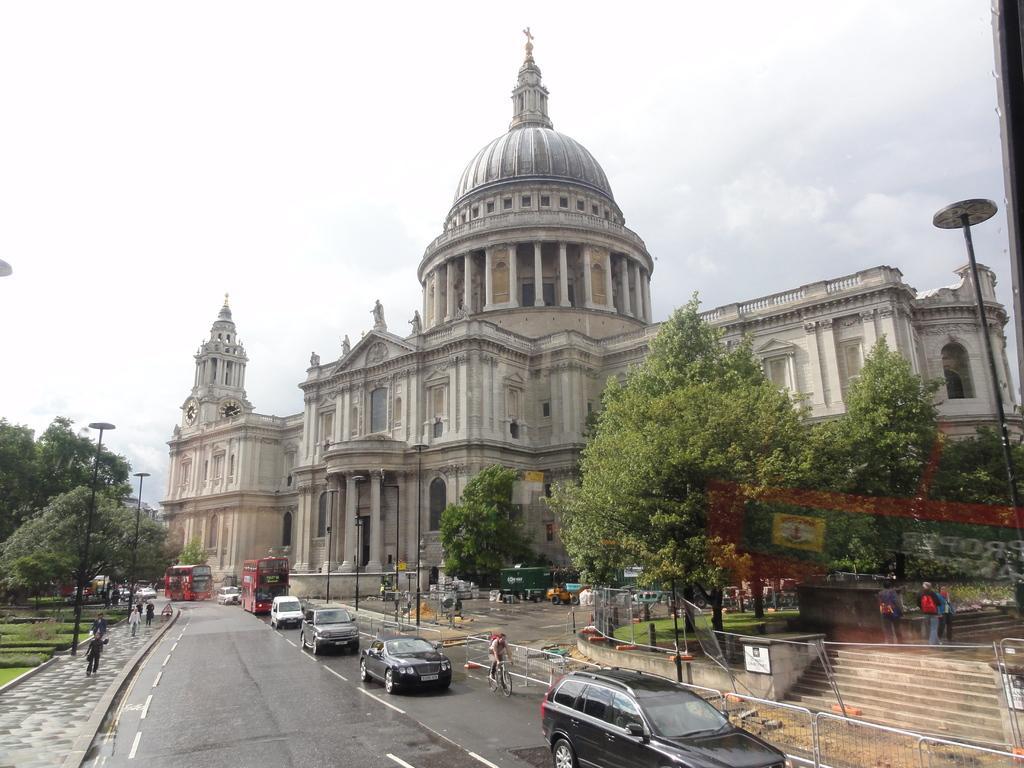Please provide a concise description of this image. In this image I can see few vehicles on the road. I can also see few persons some are walking and some are riding by-cycle, background I can see trees in green color, building and sky in white color. 